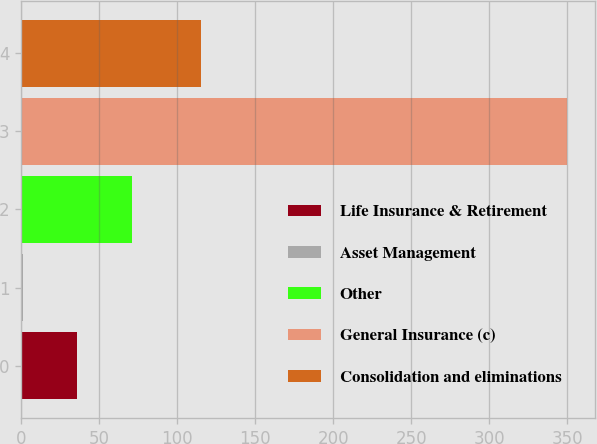Convert chart. <chart><loc_0><loc_0><loc_500><loc_500><bar_chart><fcel>Life Insurance & Retirement<fcel>Asset Management<fcel>Other<fcel>General Insurance (c)<fcel>Consolidation and eliminations<nl><fcel>35.9<fcel>1<fcel>70.8<fcel>350<fcel>115<nl></chart> 